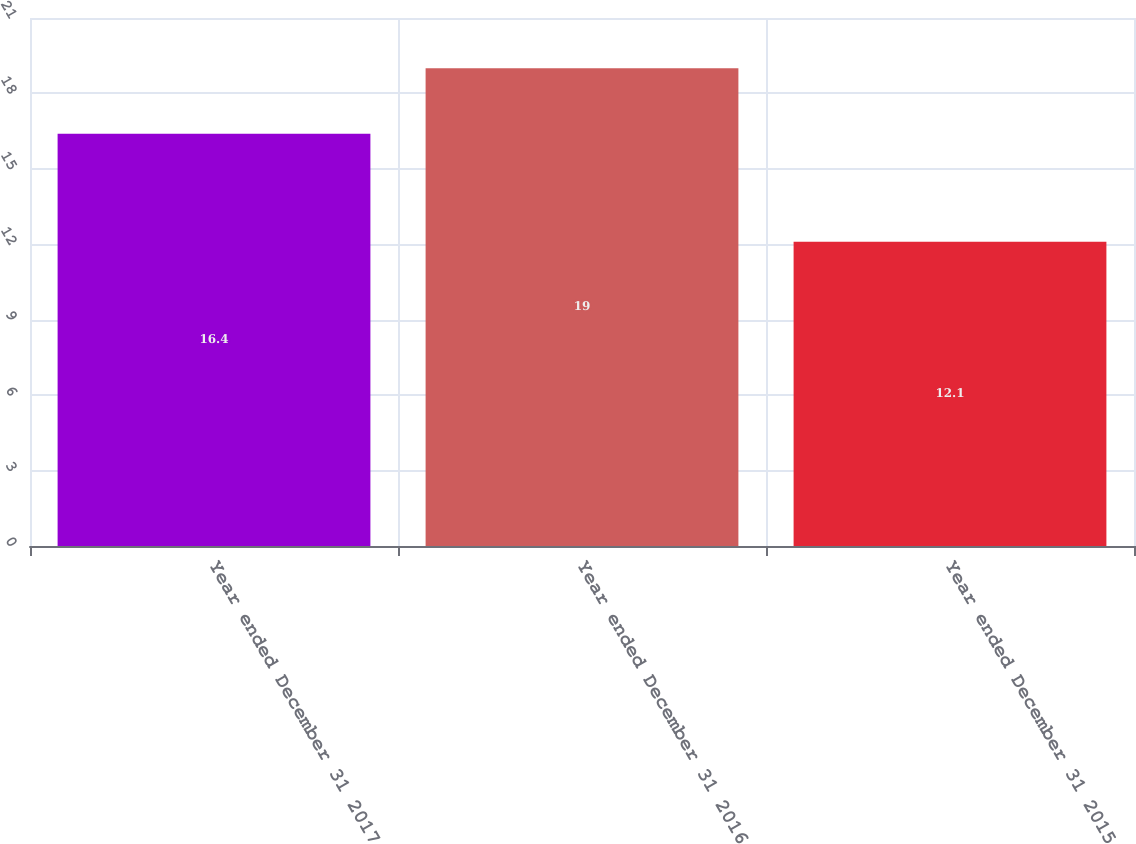<chart> <loc_0><loc_0><loc_500><loc_500><bar_chart><fcel>Year ended December 31 2017<fcel>Year ended December 31 2016<fcel>Year ended December 31 2015<nl><fcel>16.4<fcel>19<fcel>12.1<nl></chart> 